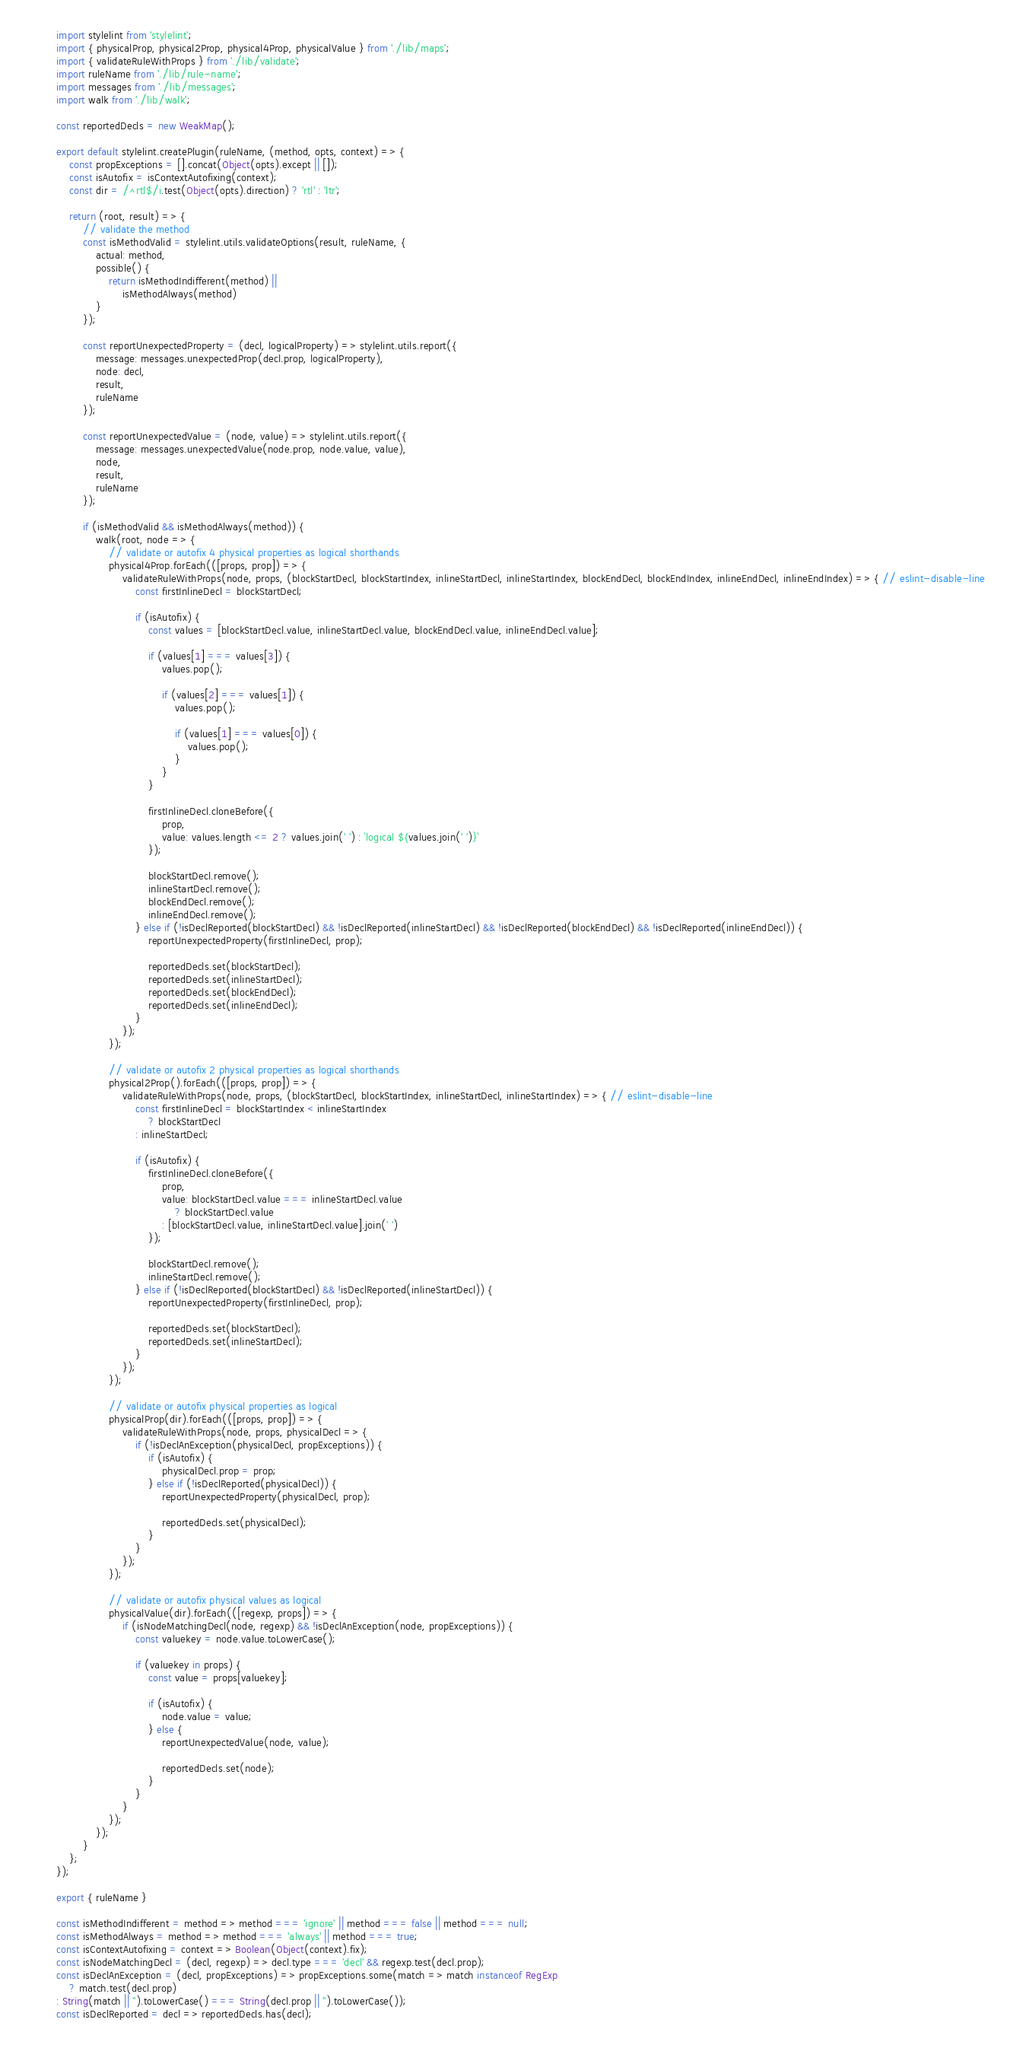Convert code to text. <code><loc_0><loc_0><loc_500><loc_500><_JavaScript_>import stylelint from 'stylelint';
import { physicalProp, physical2Prop, physical4Prop, physicalValue } from './lib/maps';
import { validateRuleWithProps } from './lib/validate';
import ruleName from './lib/rule-name';
import messages from './lib/messages';
import walk from './lib/walk';

const reportedDecls = new WeakMap();

export default stylelint.createPlugin(ruleName, (method, opts, context) => {
	const propExceptions = [].concat(Object(opts).except || []);
	const isAutofix = isContextAutofixing(context);
	const dir = /^rtl$/i.test(Object(opts).direction) ? 'rtl' : 'ltr';

	return (root, result) => {
		// validate the method
		const isMethodValid = stylelint.utils.validateOptions(result, ruleName, {
			actual: method,
			possible() {
				return isMethodIndifferent(method) ||
					isMethodAlways(method)
			}
		});

		const reportUnexpectedProperty = (decl, logicalProperty) => stylelint.utils.report({
			message: messages.unexpectedProp(decl.prop, logicalProperty),
			node: decl,
			result,
			ruleName
		});

		const reportUnexpectedValue = (node, value) => stylelint.utils.report({
			message: messages.unexpectedValue(node.prop, node.value, value),
			node,
			result,
			ruleName
		});

		if (isMethodValid && isMethodAlways(method)) {
			walk(root, node => {
				// validate or autofix 4 physical properties as logical shorthands
				physical4Prop.forEach(([props, prop]) => {
					validateRuleWithProps(node, props, (blockStartDecl, blockStartIndex, inlineStartDecl, inlineStartIndex, blockEndDecl, blockEndIndex, inlineEndDecl, inlineEndIndex) => { // eslint-disable-line
						const firstInlineDecl = blockStartDecl;

						if (isAutofix) {
							const values = [blockStartDecl.value, inlineStartDecl.value, blockEndDecl.value, inlineEndDecl.value];

							if (values[1] === values[3]) {
								values.pop();

								if (values[2] === values[1]) {
									values.pop();

									if (values[1] === values[0]) {
										values.pop();
									}
								}
							}

							firstInlineDecl.cloneBefore({
								prop,
								value: values.length <= 2 ? values.join(' ') : `logical ${values.join(' ')}`
							});

							blockStartDecl.remove();
							inlineStartDecl.remove();
							blockEndDecl.remove();
							inlineEndDecl.remove();
						} else if (!isDeclReported(blockStartDecl) && !isDeclReported(inlineStartDecl) && !isDeclReported(blockEndDecl) && !isDeclReported(inlineEndDecl)) {
							reportUnexpectedProperty(firstInlineDecl, prop);

							reportedDecls.set(blockStartDecl);
							reportedDecls.set(inlineStartDecl);
							reportedDecls.set(blockEndDecl);
							reportedDecls.set(inlineEndDecl);
						}
					});
				});

				// validate or autofix 2 physical properties as logical shorthands
				physical2Prop().forEach(([props, prop]) => {
					validateRuleWithProps(node, props, (blockStartDecl, blockStartIndex, inlineStartDecl, inlineStartIndex) => { // eslint-disable-line
						const firstInlineDecl = blockStartIndex < inlineStartIndex
							? blockStartDecl
						: inlineStartDecl;

						if (isAutofix) {
							firstInlineDecl.cloneBefore({
								prop,
								value: blockStartDecl.value === inlineStartDecl.value
									? blockStartDecl.value
								: [blockStartDecl.value, inlineStartDecl.value].join(' ')
							});

							blockStartDecl.remove();
							inlineStartDecl.remove();
						} else if (!isDeclReported(blockStartDecl) && !isDeclReported(inlineStartDecl)) {
							reportUnexpectedProperty(firstInlineDecl, prop);

							reportedDecls.set(blockStartDecl);
							reportedDecls.set(inlineStartDecl);
						}
					});
				});

				// validate or autofix physical properties as logical
				physicalProp(dir).forEach(([props, prop]) => {
					validateRuleWithProps(node, props, physicalDecl => {
						if (!isDeclAnException(physicalDecl, propExceptions)) {
							if (isAutofix) {
								physicalDecl.prop = prop;
							} else if (!isDeclReported(physicalDecl)) {
								reportUnexpectedProperty(physicalDecl, prop);

								reportedDecls.set(physicalDecl);
							}
						}
					});
				});

				// validate or autofix physical values as logical
				physicalValue(dir).forEach(([regexp, props]) => {
					if (isNodeMatchingDecl(node, regexp) && !isDeclAnException(node, propExceptions)) {
						const valuekey = node.value.toLowerCase();

						if (valuekey in props) {
							const value = props[valuekey];

							if (isAutofix) {
								node.value = value;
							} else {
								reportUnexpectedValue(node, value);

								reportedDecls.set(node);
							}
						}
					}
				});
			});
		}
	};
});

export { ruleName }

const isMethodIndifferent = method => method === 'ignore' || method === false || method === null;
const isMethodAlways = method => method === 'always' || method === true;
const isContextAutofixing = context => Boolean(Object(context).fix);
const isNodeMatchingDecl = (decl, regexp) => decl.type === 'decl' && regexp.test(decl.prop);
const isDeclAnException = (decl, propExceptions) => propExceptions.some(match => match instanceof RegExp
	? match.test(decl.prop)
: String(match || '').toLowerCase() === String(decl.prop || '').toLowerCase());
const isDeclReported = decl => reportedDecls.has(decl);
</code> 